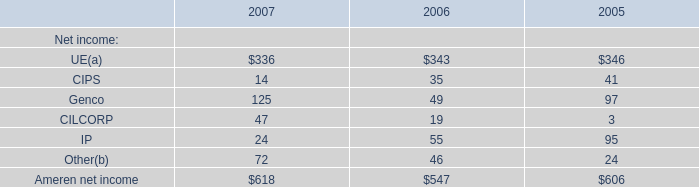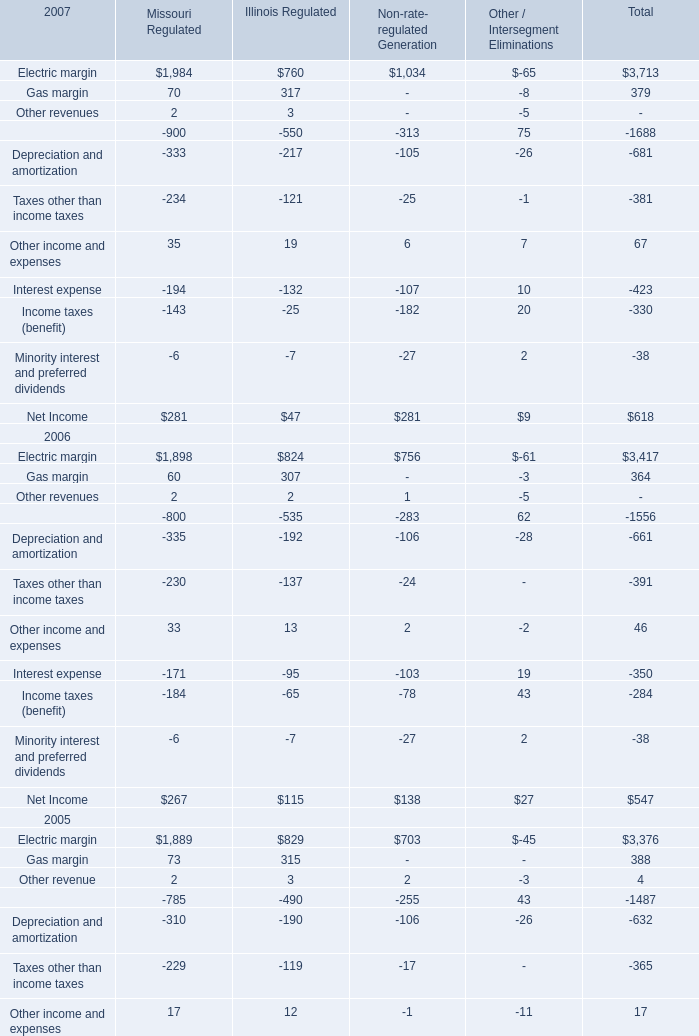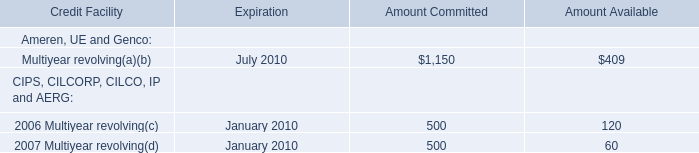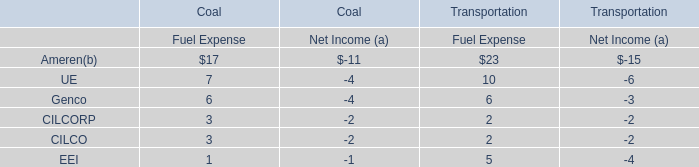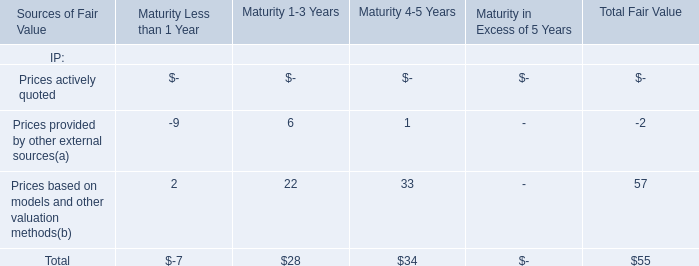Which Net income occupies the greatest proportion in 2007? 
Answer: UE. 